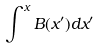<formula> <loc_0><loc_0><loc_500><loc_500>\int ^ { x } B ( x ^ { \prime } ) d x ^ { \prime }</formula> 